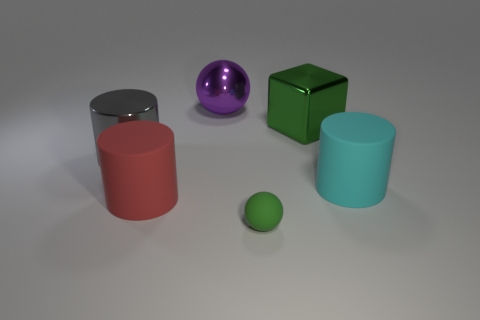Are there any other things that have the same size as the green rubber ball?
Provide a short and direct response. No. The large rubber object behind the matte cylinder that is left of the large rubber thing that is to the right of the rubber sphere is what shape?
Provide a succinct answer. Cylinder. There is a metal block that is the same size as the gray metallic object; what is its color?
Your answer should be very brief. Green. How many other objects have the same shape as the purple object?
Offer a very short reply. 1. There is a red rubber object; is it the same size as the sphere right of the large sphere?
Keep it short and to the point. No. There is a rubber thing that is left of the ball that is in front of the large ball; what is its shape?
Your answer should be compact. Cylinder. Are there fewer gray metallic cylinders that are on the right side of the big cyan matte object than tiny red shiny cubes?
Offer a very short reply. No. There is a big shiny thing that is the same color as the matte ball; what is its shape?
Your response must be concise. Cube. How many gray metal objects have the same size as the cyan rubber cylinder?
Offer a terse response. 1. The green object that is to the left of the green metallic cube has what shape?
Make the answer very short. Sphere. 